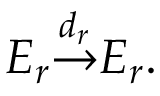Convert formula to latex. <formula><loc_0><loc_0><loc_500><loc_500>E _ { r } { \overset { d _ { r } } { \to } } E _ { r } .</formula> 